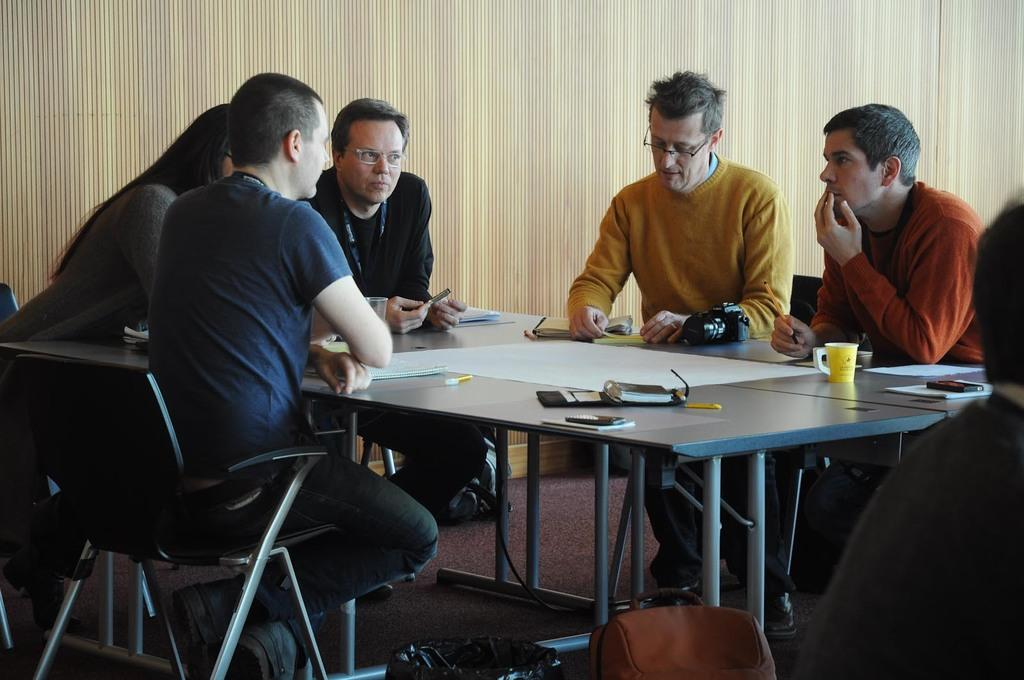What is the person in the image doing? The person is sitting on a chair. What is in front of the chair? There is a table in front of the chair. What can be seen on the table? There are papers, a cup, and other objects on the table. What is at the back of the scene? There is a curtain at the back of the scene. What type of canvas is being used to paint a picture in the image? There is no canvas or painting activity present in the image. 